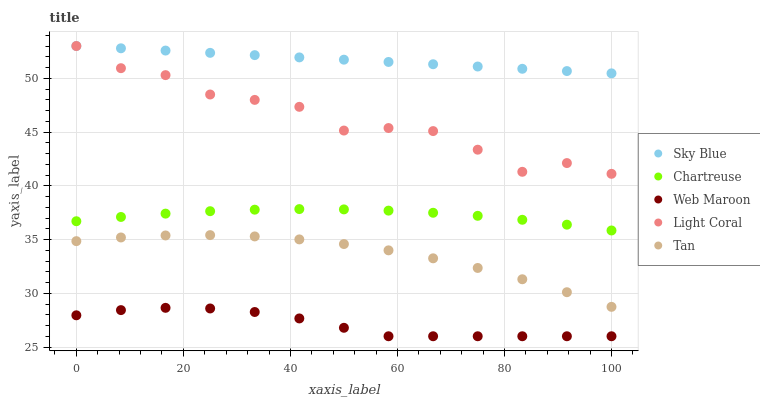Does Web Maroon have the minimum area under the curve?
Answer yes or no. Yes. Does Sky Blue have the maximum area under the curve?
Answer yes or no. Yes. Does Chartreuse have the minimum area under the curve?
Answer yes or no. No. Does Chartreuse have the maximum area under the curve?
Answer yes or no. No. Is Sky Blue the smoothest?
Answer yes or no. Yes. Is Light Coral the roughest?
Answer yes or no. Yes. Is Chartreuse the smoothest?
Answer yes or no. No. Is Chartreuse the roughest?
Answer yes or no. No. Does Web Maroon have the lowest value?
Answer yes or no. Yes. Does Chartreuse have the lowest value?
Answer yes or no. No. Does Sky Blue have the highest value?
Answer yes or no. Yes. Does Chartreuse have the highest value?
Answer yes or no. No. Is Web Maroon less than Light Coral?
Answer yes or no. Yes. Is Light Coral greater than Web Maroon?
Answer yes or no. Yes. Does Light Coral intersect Sky Blue?
Answer yes or no. Yes. Is Light Coral less than Sky Blue?
Answer yes or no. No. Is Light Coral greater than Sky Blue?
Answer yes or no. No. Does Web Maroon intersect Light Coral?
Answer yes or no. No. 